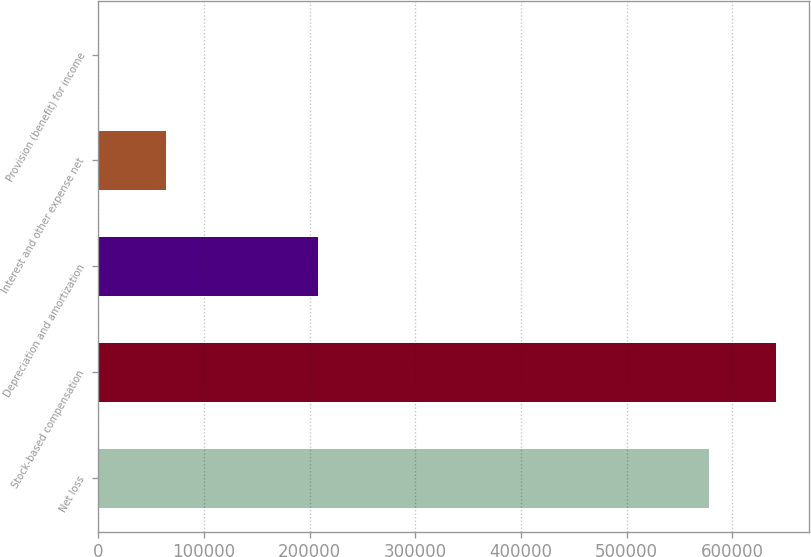<chart> <loc_0><loc_0><loc_500><loc_500><bar_chart><fcel>Net loss<fcel>Stock-based compensation<fcel>Depreciation and amortization<fcel>Interest and other expense net<fcel>Provision (benefit) for income<nl><fcel>577820<fcel>640927<fcel>208165<fcel>63637.6<fcel>531<nl></chart> 